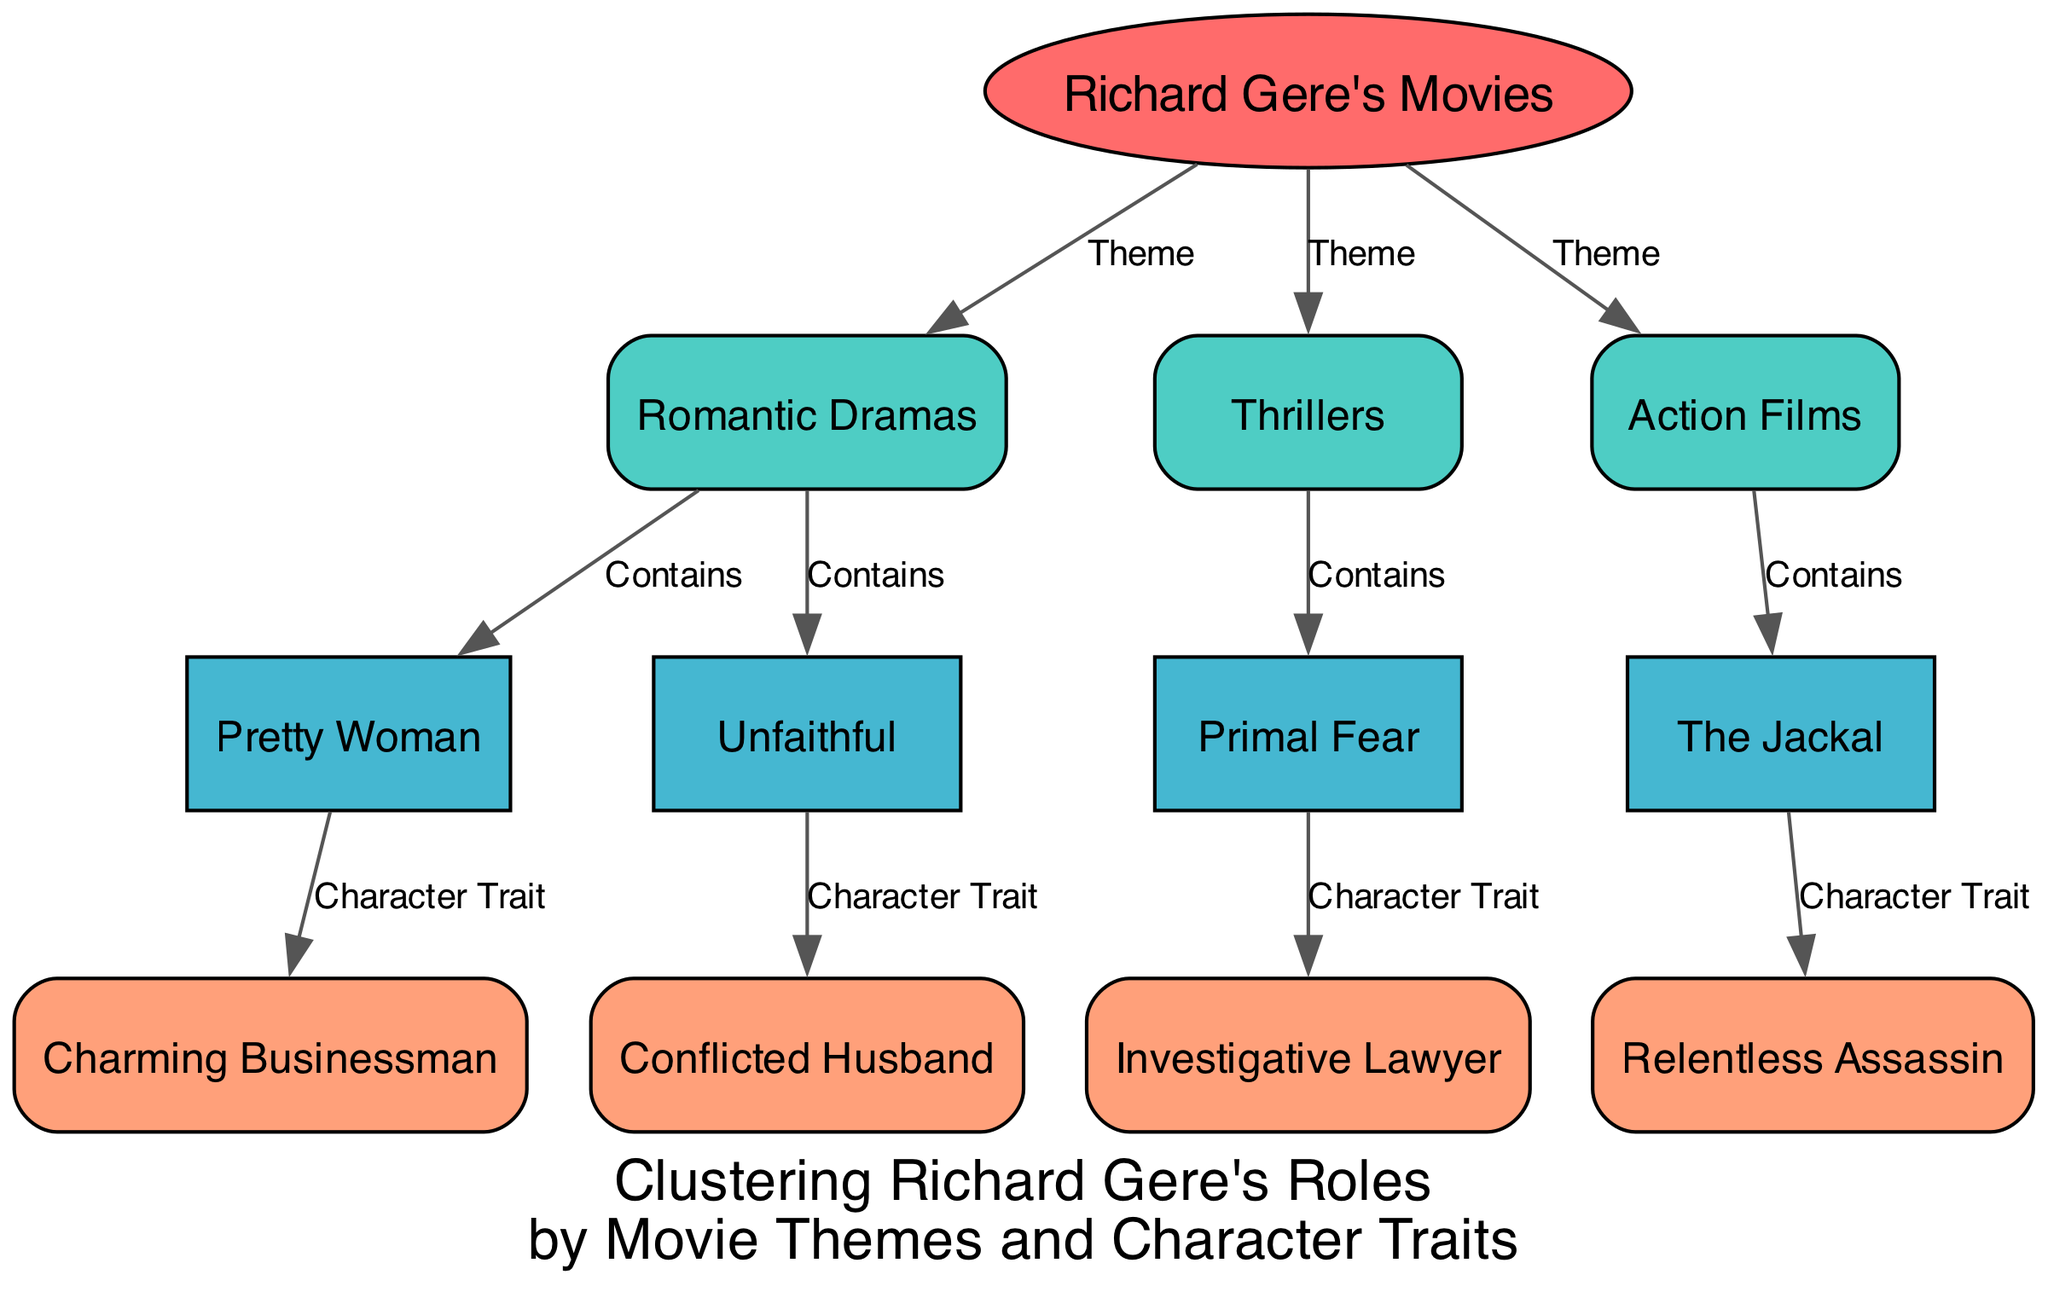What is the main category of the diagram? The main category in the diagram is represented by the root node labeled "Richard Gere's Movies", which signifies the overall focus of the diagram.
Answer: Richard Gere's Movies How many movie themes are present in the diagram? The diagram contains three different movie themes: Romantic Dramas, Thrillers, and Action Films, as indicated by the theme nodes connected to the root node.
Answer: 3 Which movie falls under the theme of Romantic Dramas? The movie "Pretty Woman" and "Unfaithful" are both connected to the Romantic Dramas theme node, showing that they belong under this category.
Answer: Pretty Woman, Unfaithful How many character traits are associated with the movie "Primal Fear"? "Primal Fear" is associated with one character trait, which is "Investigative Lawyer," as shown by the edge connecting the movie node to the character trait node.
Answer: 1 Which character trait is linked to the movie "The Jackal"? The character trait linked to the movie "The Jackal" is "Relentless Assassin," which is connected through the edge labeled as a character trait associated with this movie.
Answer: Relentless Assassin What type of diagram is this? This diagram is a Machine Learning Diagram that visually represents the clustering of Richard Gere's roles by movie themes and character traits, as it illustrates relationships between different categories.
Answer: Machine Learning Diagram Which character traits are associated with Romantic Dramas? The character traits associated with the Romantic Dramas are "Charming Businessman" and "Conflicted Husband," both movies under this theme link to these traits.
Answer: Charming Businessman, Conflicted Husband How many edges connect the theme of Thrillers to movies? There is one edge connecting the theme of Thrillers to movies, showcasing that "Primal Fear" is associated with this theme.
Answer: 1 